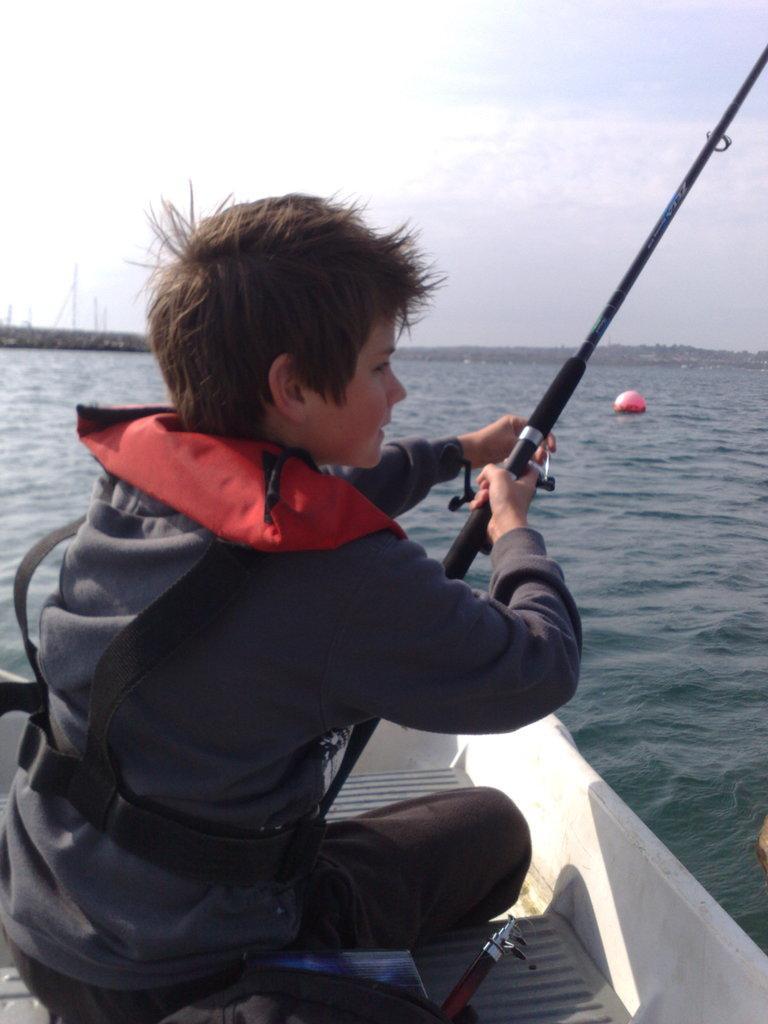Could you give a brief overview of what you see in this image? This is an outside view. Here I can see a boy wearing a blue color jacket, sitting on the boat and fishing by holding a stick in the hands. He is looking towards the right side. Here I can see the water which is looking like a sea. On the top of the image I can see the sky. 